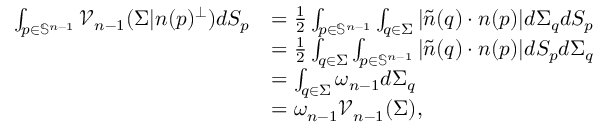<formula> <loc_0><loc_0><loc_500><loc_500>\begin{array} { r l } { \int _ { p \in \mathbb { S } ^ { n - 1 } } \mathcal { V } _ { n - 1 } ( \Sigma | n ( p ) ^ { \perp } ) d S _ { p } } & { = \frac { 1 } { 2 } \int _ { p \in \mathbb { S } ^ { n - 1 } } \int _ { q \in \Sigma } | \tilde { n } ( q ) \cdot { n } ( p ) | d \Sigma _ { q } d S _ { p } } \\ & { = \frac { 1 } { 2 } \int _ { q \in \Sigma } \int _ { p \in \mathbb { S } ^ { n - 1 } } | \tilde { n } ( q ) \cdot { n } ( p ) | d S _ { p } d \Sigma _ { q } } \\ & { = \int _ { q \in \Sigma } \omega _ { n - 1 } d \Sigma _ { q } } \\ & { = \omega _ { n - 1 } \mathcal { V } _ { n - 1 } ( \Sigma ) , } \end{array}</formula> 